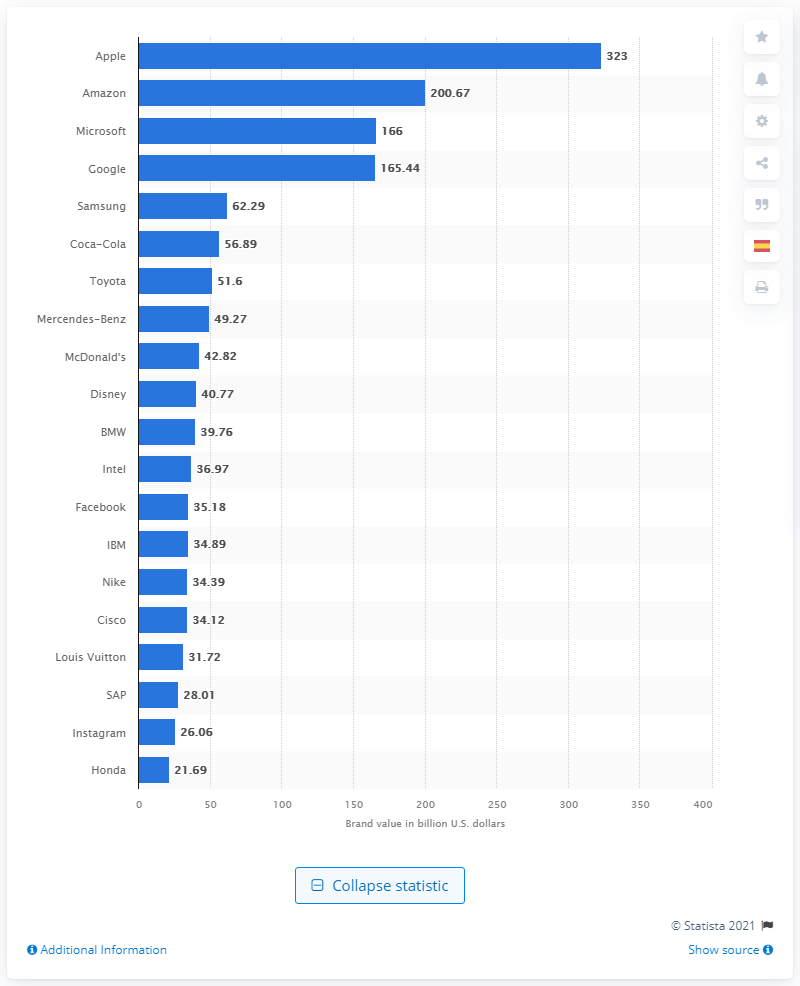Draw attention to some important aspects in this diagram. Apple's value in dollars is approximately 323. 